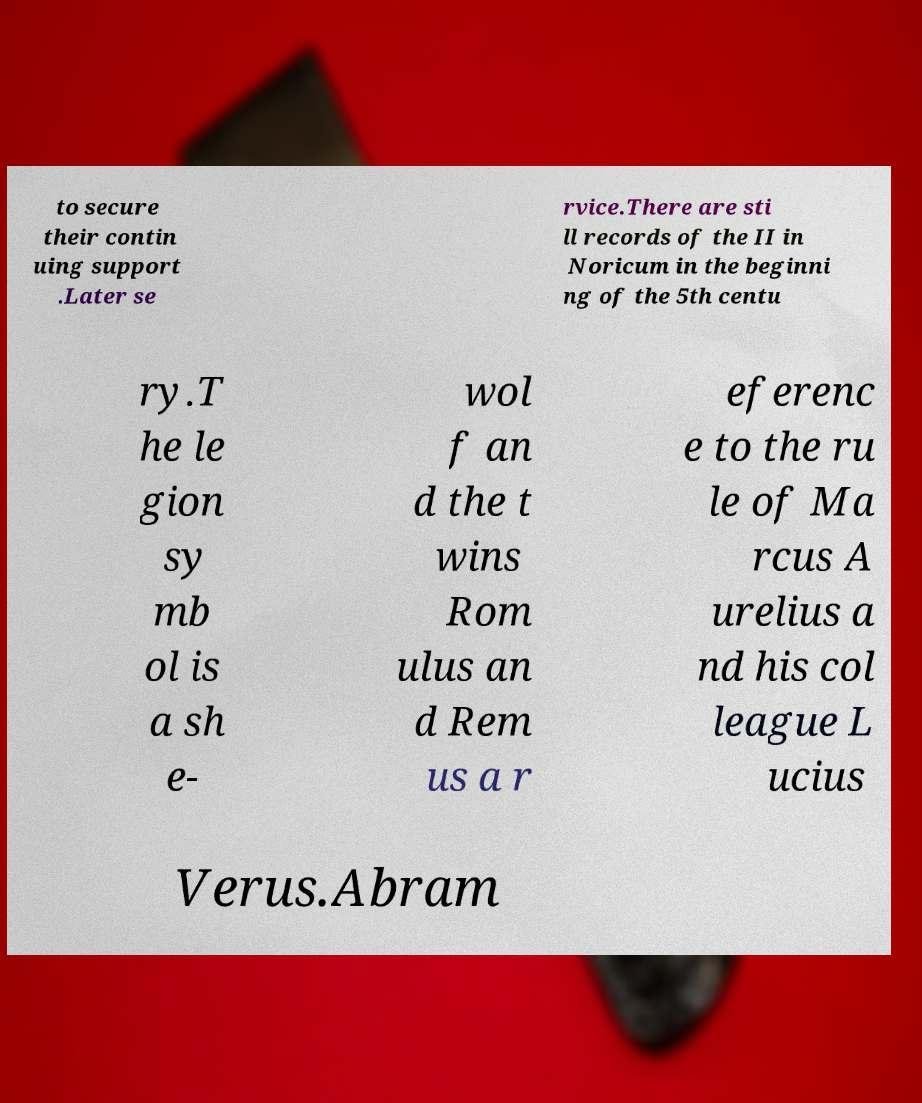There's text embedded in this image that I need extracted. Can you transcribe it verbatim? to secure their contin uing support .Later se rvice.There are sti ll records of the II in Noricum in the beginni ng of the 5th centu ry.T he le gion sy mb ol is a sh e- wol f an d the t wins Rom ulus an d Rem us a r eferenc e to the ru le of Ma rcus A urelius a nd his col league L ucius Verus.Abram 